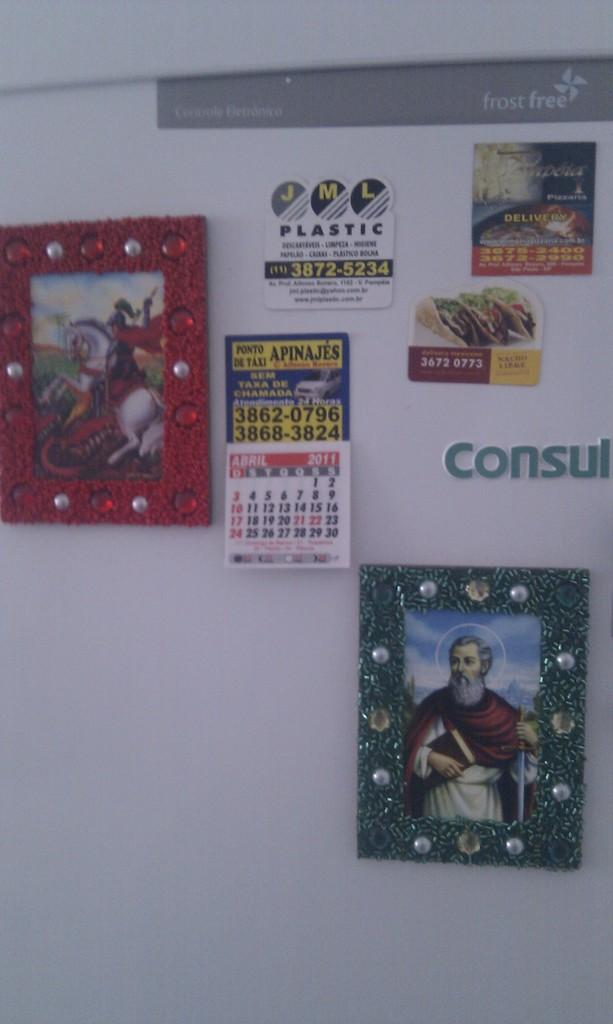<image>
Give a short and clear explanation of the subsequent image. Magnets are shown on a refridgerator; one of them says JML Plastic. 